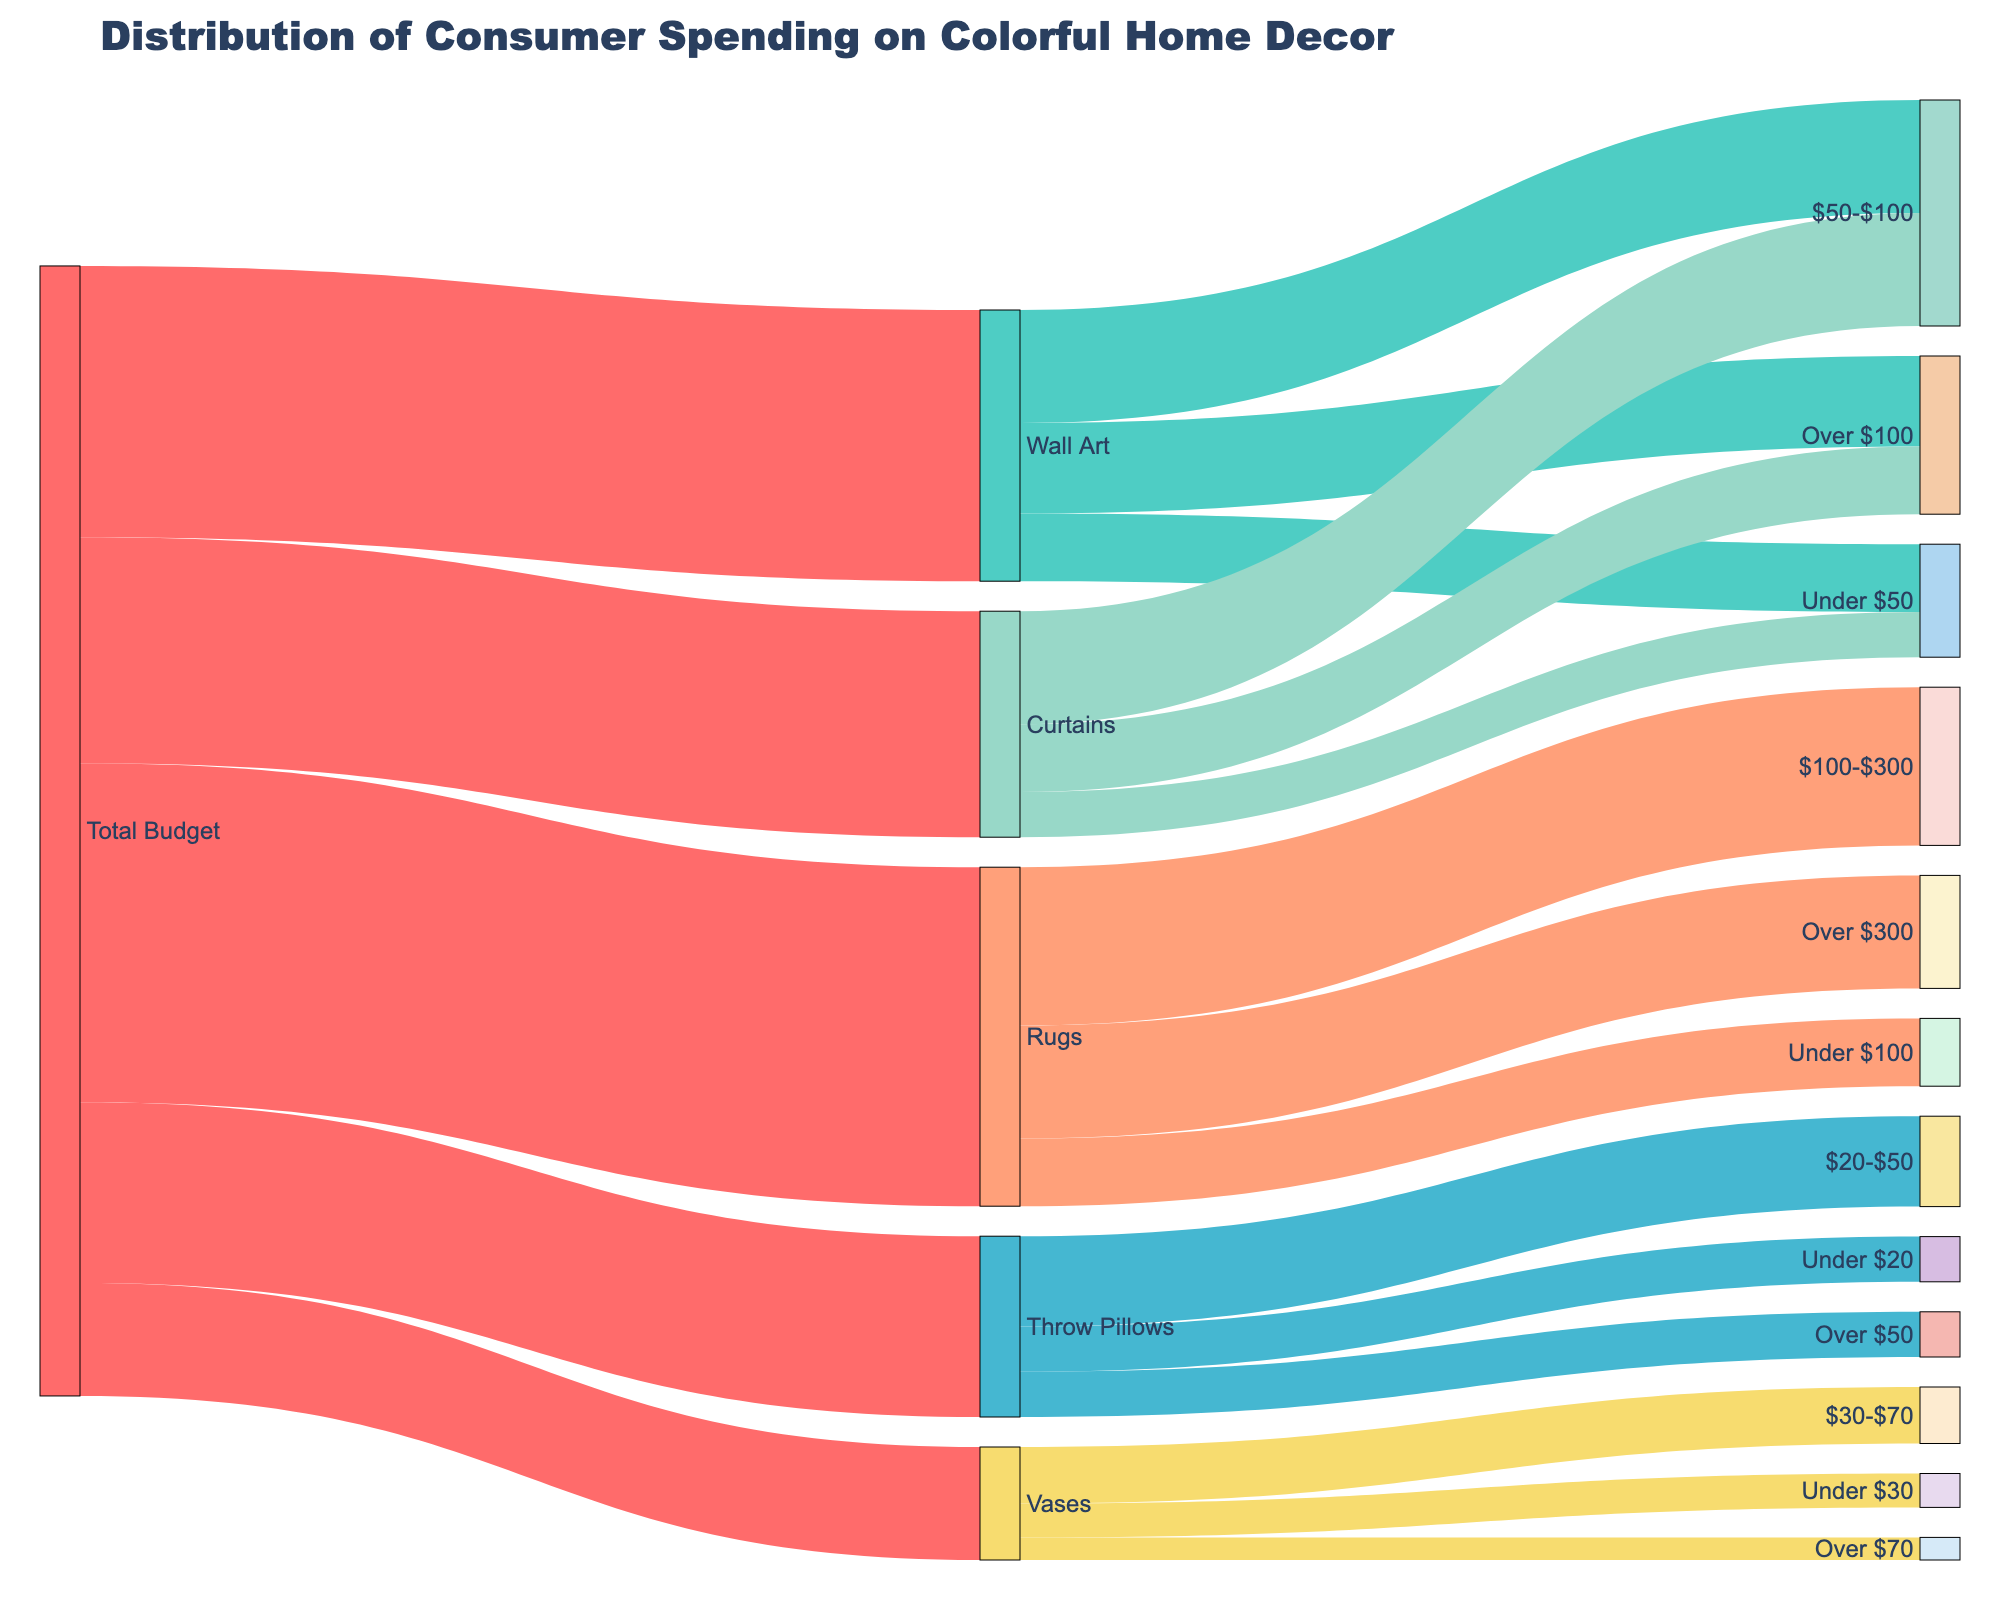What's the title of the diagram? The title is displayed at the top of the diagram. It helps to quickly understand the main topic.
Answer: Distribution of Consumer Spending on Colorful Home Decor Which product category has the highest total budget allocation? By looking at the widths of the flows from 'Total Budget' to the different product categories, the one with the widest flow represents the highest allocation.
Answer: Rugs What is the total budget allocated for Wall Art? The width of the flow from 'Total Budget' to 'Wall Art' indicates the allocation.
Answer: 1200 Which price range has the highest spending in the Rugs category? To determine this, look at the flows between 'Rugs' and its price ranges. The value of 'Rugs, $100-$300' is the largest.
Answer: $100-$300 How much is spent on Throw Pillows in the '$20-$50' range? Locate the flow between 'Throw Pillows' and '$20-$50' to find the value. It's indicated to be 400.
Answer: 400 Compare the spending on Vases in the 'Under $30' and 'Over $70' ranges. Which is larger? The flows from 'Vases' to 'Under $30' and to 'Over $70' show the values. Spending is higher in the 'Under $30' range (150 vs. 100).
Answer: Under $30 What is the sum of the budget allocated to Wall Art and Curtains? Add the values for Wall Art (1200) and Curtains (1000) from the 'Total Budget' flows.
Answer: 2200 Which product category has the lowest budget allocation, and what is the amount? By comparing the widths of flows from 'Total Budget' to each product category, Vases has the smallest flow.
Answer: Vases, 500 What is the combined spending on items in the Under $50 price range across all categories? Find the connections for each category to their respective 'Under $50' price ranges and sum them: Wall Art (300), Throw Pillows (200), Rugs (300), and Curtains (200). 300 + 200 + 300 + 200 = 1000
Answer: 1000 Considering all product categories, which has the most diverse spending across different price ranges? Investigate the number of price ranges and values connected to each product category. Wall Art, Throw Pillows, Rugs, Curtains, and Vases all have three price ranges listed. To find the diversity in terms of spread, Rugs have the widest range spread.
Answer: Rugs 